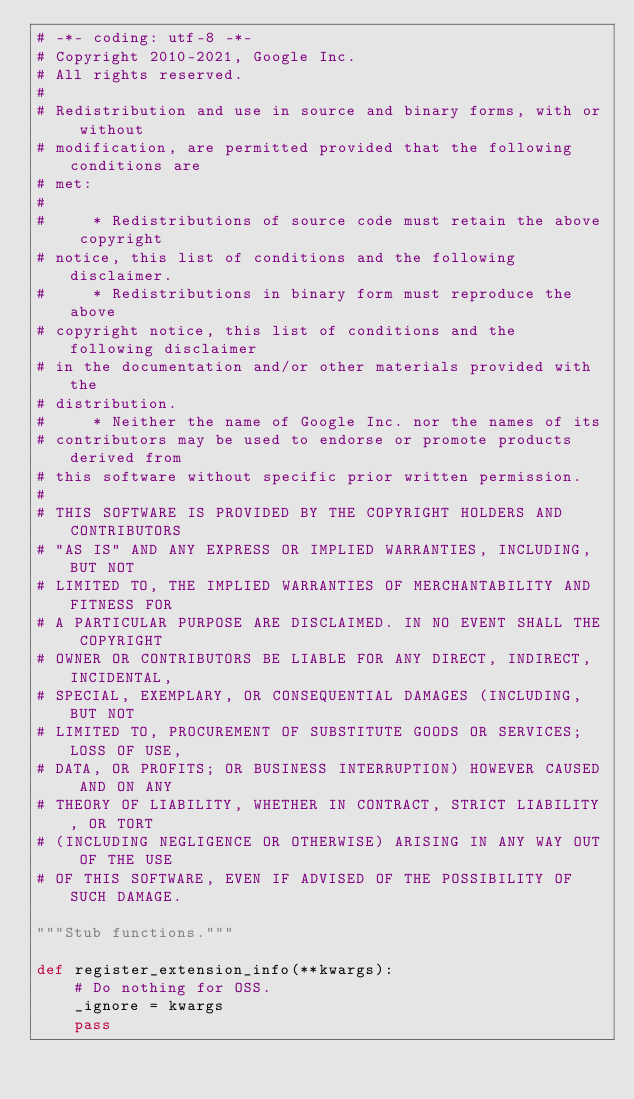Convert code to text. <code><loc_0><loc_0><loc_500><loc_500><_Python_># -*- coding: utf-8 -*-
# Copyright 2010-2021, Google Inc.
# All rights reserved.
#
# Redistribution and use in source and binary forms, with or without
# modification, are permitted provided that the following conditions are
# met:
#
#     * Redistributions of source code must retain the above copyright
# notice, this list of conditions and the following disclaimer.
#     * Redistributions in binary form must reproduce the above
# copyright notice, this list of conditions and the following disclaimer
# in the documentation and/or other materials provided with the
# distribution.
#     * Neither the name of Google Inc. nor the names of its
# contributors may be used to endorse or promote products derived from
# this software without specific prior written permission.
#
# THIS SOFTWARE IS PROVIDED BY THE COPYRIGHT HOLDERS AND CONTRIBUTORS
# "AS IS" AND ANY EXPRESS OR IMPLIED WARRANTIES, INCLUDING, BUT NOT
# LIMITED TO, THE IMPLIED WARRANTIES OF MERCHANTABILITY AND FITNESS FOR
# A PARTICULAR PURPOSE ARE DISCLAIMED. IN NO EVENT SHALL THE COPYRIGHT
# OWNER OR CONTRIBUTORS BE LIABLE FOR ANY DIRECT, INDIRECT, INCIDENTAL,
# SPECIAL, EXEMPLARY, OR CONSEQUENTIAL DAMAGES (INCLUDING, BUT NOT
# LIMITED TO, PROCUREMENT OF SUBSTITUTE GOODS OR SERVICES; LOSS OF USE,
# DATA, OR PROFITS; OR BUSINESS INTERRUPTION) HOWEVER CAUSED AND ON ANY
# THEORY OF LIABILITY, WHETHER IN CONTRACT, STRICT LIABILITY, OR TORT
# (INCLUDING NEGLIGENCE OR OTHERWISE) ARISING IN ANY WAY OUT OF THE USE
# OF THIS SOFTWARE, EVEN IF ADVISED OF THE POSSIBILITY OF SUCH DAMAGE.

"""Stub functions."""

def register_extension_info(**kwargs):
    # Do nothing for OSS.
    _ignore = kwargs
    pass
</code> 